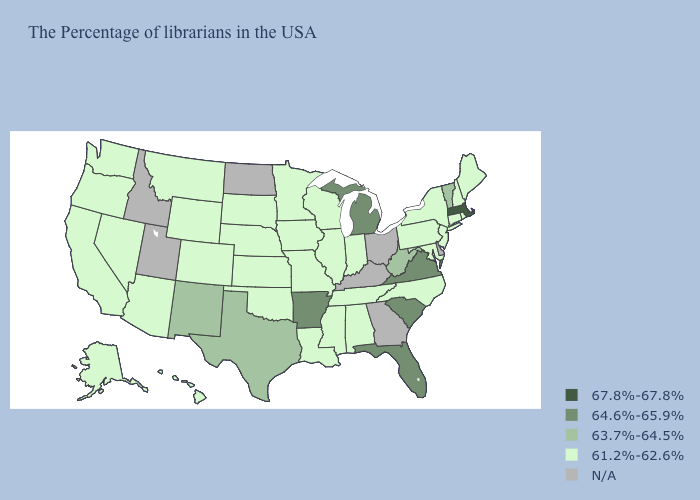Name the states that have a value in the range 64.6%-65.9%?
Give a very brief answer. Virginia, South Carolina, Florida, Michigan, Arkansas. Among the states that border Colorado , which have the highest value?
Be succinct. New Mexico. Which states hav the highest value in the MidWest?
Be succinct. Michigan. Does Massachusetts have the lowest value in the Northeast?
Write a very short answer. No. Name the states that have a value in the range N/A?
Short answer required. Delaware, Ohio, Georgia, Kentucky, North Dakota, Utah, Idaho. Which states have the lowest value in the South?
Keep it brief. Maryland, North Carolina, Alabama, Tennessee, Mississippi, Louisiana, Oklahoma. What is the value of Wyoming?
Be succinct. 61.2%-62.6%. Name the states that have a value in the range 67.8%-67.8%?
Keep it brief. Massachusetts. What is the lowest value in the MidWest?
Be succinct. 61.2%-62.6%. Does Michigan have the lowest value in the MidWest?
Be succinct. No. Among the states that border Washington , which have the highest value?
Be succinct. Oregon. Name the states that have a value in the range 63.7%-64.5%?
Quick response, please. Vermont, West Virginia, Texas, New Mexico. How many symbols are there in the legend?
Quick response, please. 5. 